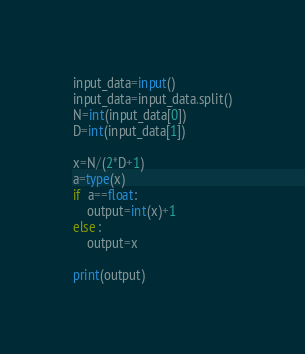Convert code to text. <code><loc_0><loc_0><loc_500><loc_500><_Python_>input_data=input()
input_data=input_data.split()
N=int(input_data[0])
D=int(input_data[1])

x=N/(2*D+1)
a=type(x)
if  a==float:
    output=int(x)+1
else :
    output=x

print(output)</code> 